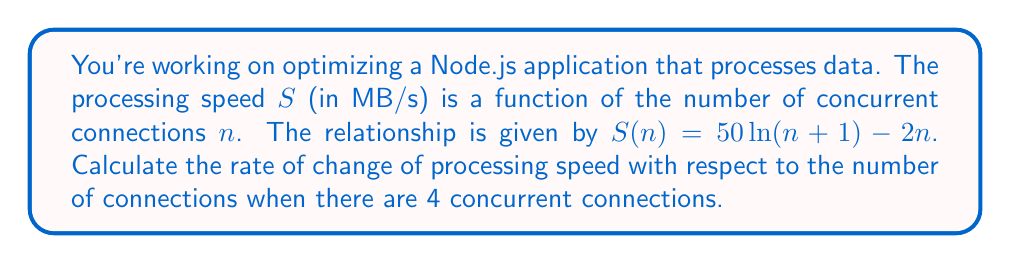Can you solve this math problem? To find the rate of change of processing speed with respect to the number of connections, we need to calculate the derivative of $S(n)$ and then evaluate it at $n=4$.

Step 1: Calculate the derivative of $S(n)$
$$\frac{d}{dn}S(n) = \frac{d}{dn}[50\ln(n+1) - 2n]$$

Using the chain rule and the power rule:
$$\frac{d}{dn}S(n) = 50 \cdot \frac{1}{n+1} - 2$$

Step 2: Simplify the derivative
$$S'(n) = \frac{50}{n+1} - 2$$

Step 3: Evaluate the derivative at $n=4$
$$S'(4) = \frac{50}{4+1} - 2$$
$$S'(4) = \frac{50}{5} - 2$$
$$S'(4) = 10 - 2 = 8$$

Therefore, when there are 4 concurrent connections, the rate of change of processing speed is 8 MB/s per additional connection.
Answer: 8 MB/s per connection 